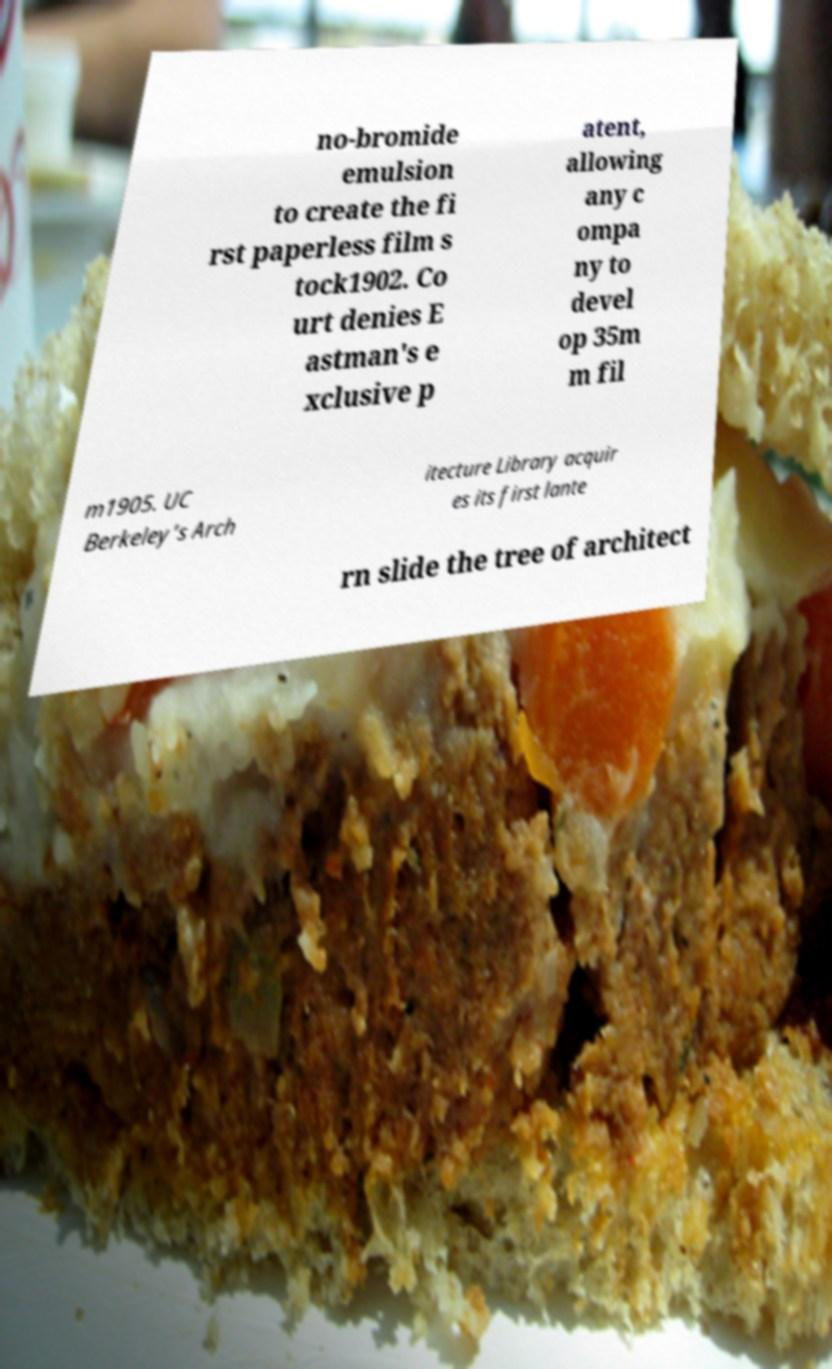Could you extract and type out the text from this image? no-bromide emulsion to create the fi rst paperless film s tock1902. Co urt denies E astman's e xclusive p atent, allowing any c ompa ny to devel op 35m m fil m1905. UC Berkeley’s Arch itecture Library acquir es its first lante rn slide the tree of architect 